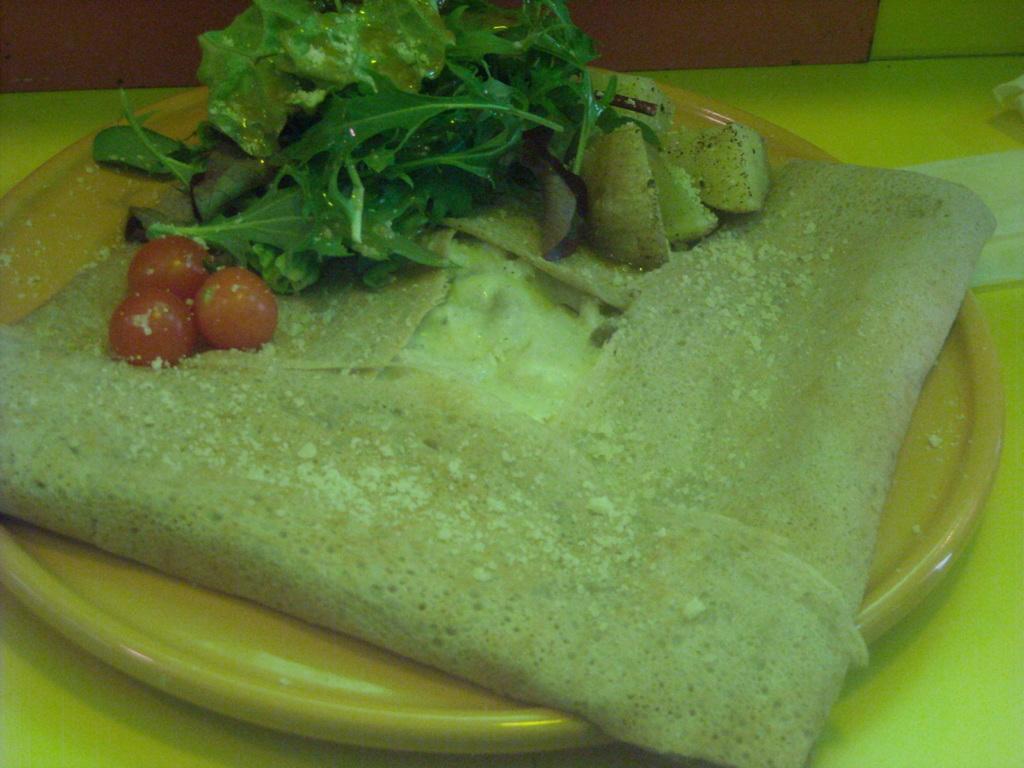How would you summarize this image in a sentence or two? In this image I can see there is a some food placed on the plate and it is placed on the table 